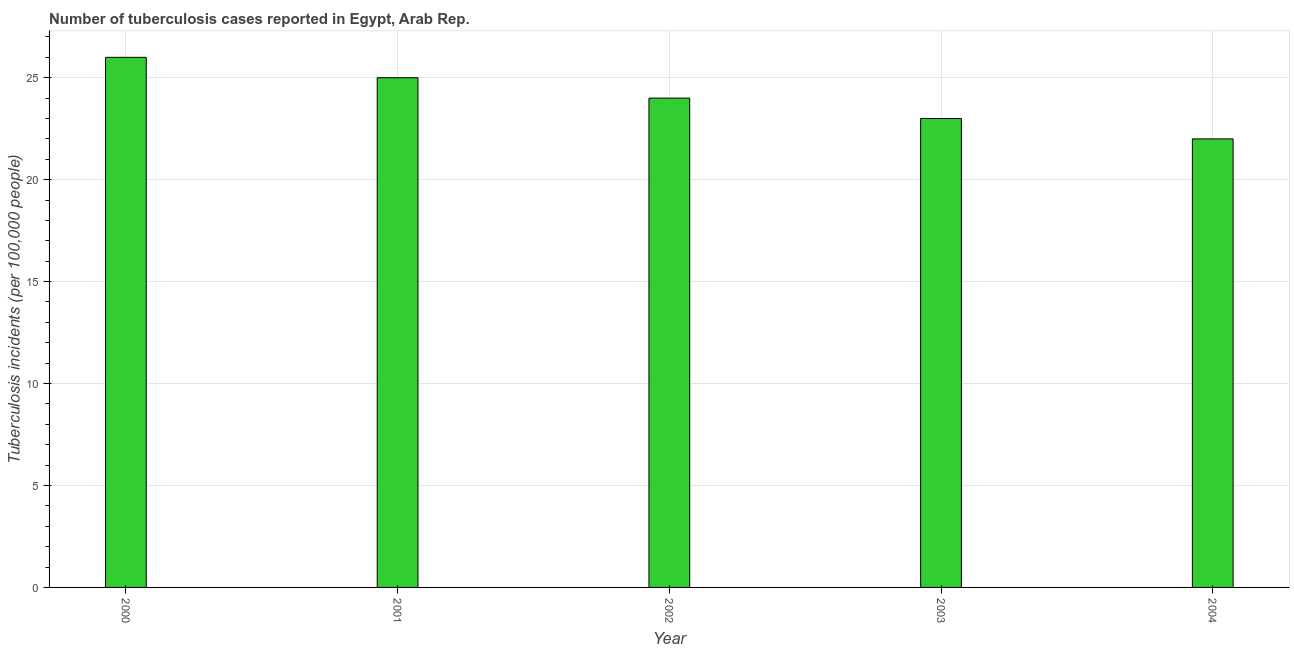Does the graph contain any zero values?
Your answer should be very brief. No. What is the title of the graph?
Offer a very short reply. Number of tuberculosis cases reported in Egypt, Arab Rep. What is the label or title of the Y-axis?
Offer a terse response. Tuberculosis incidents (per 100,0 people). What is the number of tuberculosis incidents in 2003?
Your answer should be very brief. 23. Across all years, what is the maximum number of tuberculosis incidents?
Your response must be concise. 26. Across all years, what is the minimum number of tuberculosis incidents?
Give a very brief answer. 22. In which year was the number of tuberculosis incidents maximum?
Make the answer very short. 2000. In which year was the number of tuberculosis incidents minimum?
Your answer should be compact. 2004. What is the sum of the number of tuberculosis incidents?
Offer a very short reply. 120. What is the median number of tuberculosis incidents?
Offer a terse response. 24. Do a majority of the years between 2002 and 2004 (inclusive) have number of tuberculosis incidents greater than 15 ?
Provide a short and direct response. Yes. What is the ratio of the number of tuberculosis incidents in 2000 to that in 2003?
Ensure brevity in your answer.  1.13. Is the sum of the number of tuberculosis incidents in 2001 and 2002 greater than the maximum number of tuberculosis incidents across all years?
Your answer should be compact. Yes. What is the difference between two consecutive major ticks on the Y-axis?
Your response must be concise. 5. What is the difference between the Tuberculosis incidents (per 100,000 people) in 2000 and 2003?
Make the answer very short. 3. What is the difference between the Tuberculosis incidents (per 100,000 people) in 2000 and 2004?
Your answer should be very brief. 4. What is the difference between the Tuberculosis incidents (per 100,000 people) in 2001 and 2002?
Your response must be concise. 1. What is the difference between the Tuberculosis incidents (per 100,000 people) in 2001 and 2003?
Make the answer very short. 2. What is the difference between the Tuberculosis incidents (per 100,000 people) in 2002 and 2004?
Provide a short and direct response. 2. What is the difference between the Tuberculosis incidents (per 100,000 people) in 2003 and 2004?
Provide a short and direct response. 1. What is the ratio of the Tuberculosis incidents (per 100,000 people) in 2000 to that in 2001?
Provide a short and direct response. 1.04. What is the ratio of the Tuberculosis incidents (per 100,000 people) in 2000 to that in 2002?
Provide a short and direct response. 1.08. What is the ratio of the Tuberculosis incidents (per 100,000 people) in 2000 to that in 2003?
Keep it short and to the point. 1.13. What is the ratio of the Tuberculosis incidents (per 100,000 people) in 2000 to that in 2004?
Provide a succinct answer. 1.18. What is the ratio of the Tuberculosis incidents (per 100,000 people) in 2001 to that in 2002?
Provide a short and direct response. 1.04. What is the ratio of the Tuberculosis incidents (per 100,000 people) in 2001 to that in 2003?
Provide a succinct answer. 1.09. What is the ratio of the Tuberculosis incidents (per 100,000 people) in 2001 to that in 2004?
Keep it short and to the point. 1.14. What is the ratio of the Tuberculosis incidents (per 100,000 people) in 2002 to that in 2003?
Provide a short and direct response. 1.04. What is the ratio of the Tuberculosis incidents (per 100,000 people) in 2002 to that in 2004?
Your response must be concise. 1.09. What is the ratio of the Tuberculosis incidents (per 100,000 people) in 2003 to that in 2004?
Provide a short and direct response. 1.04. 